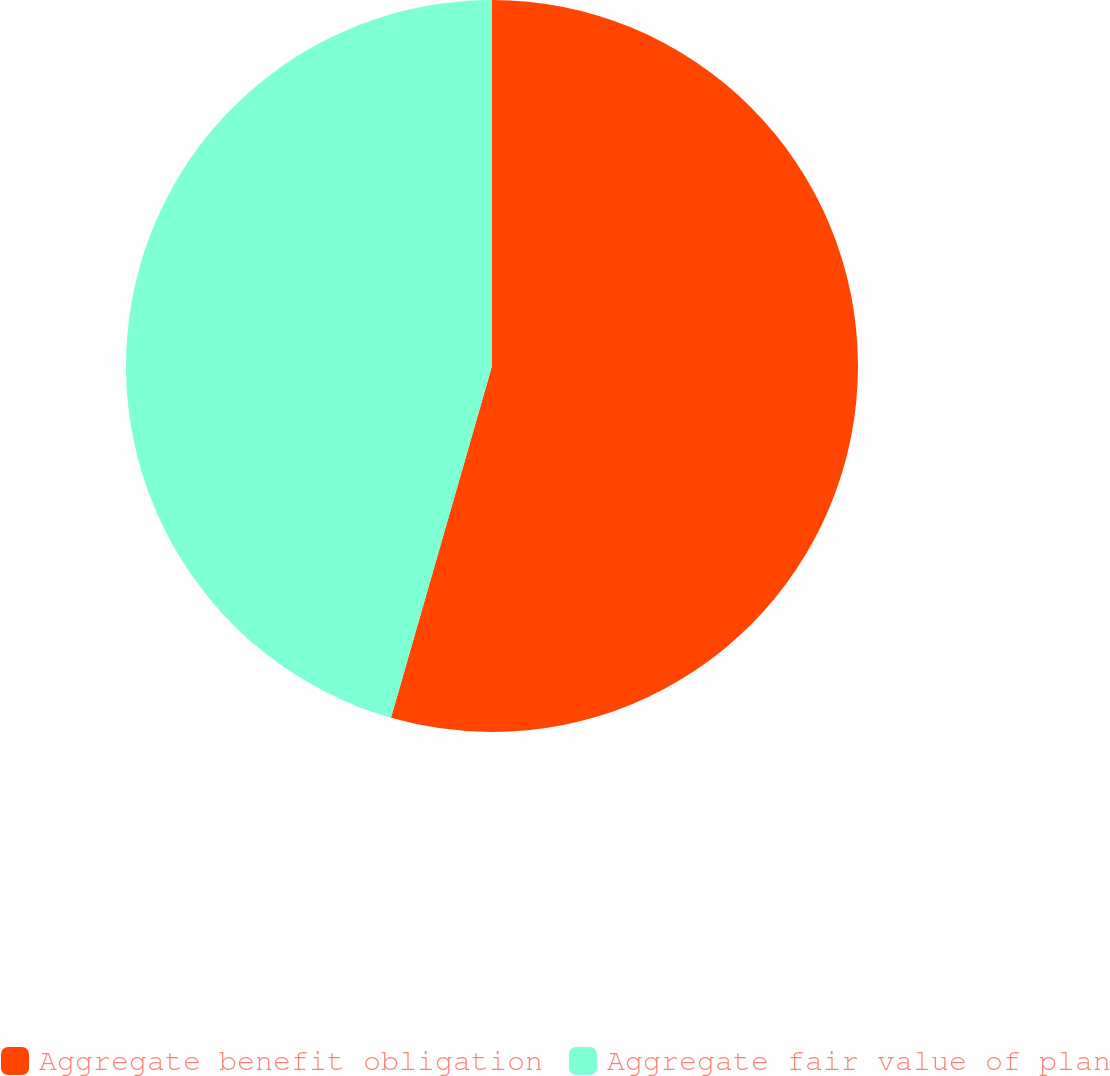<chart> <loc_0><loc_0><loc_500><loc_500><pie_chart><fcel>Aggregate benefit obligation<fcel>Aggregate fair value of plan<nl><fcel>54.45%<fcel>45.55%<nl></chart> 